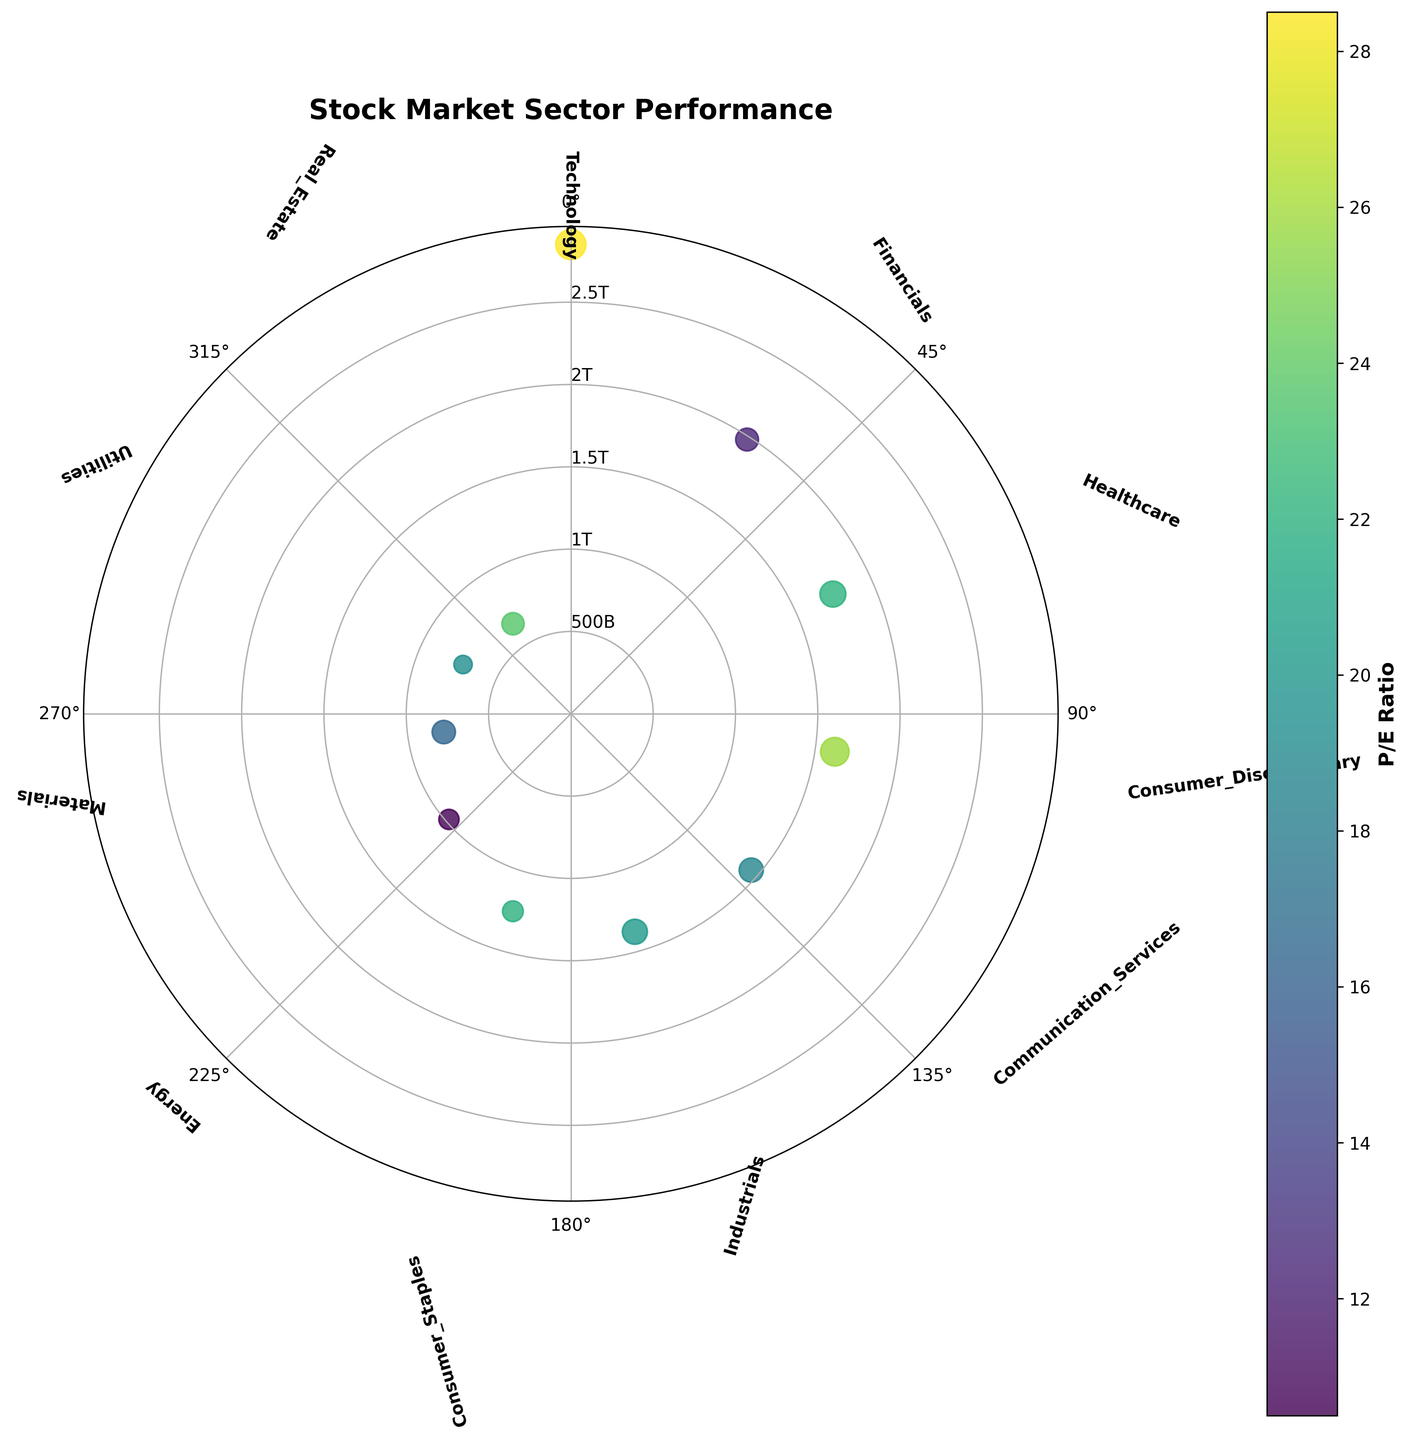What is the title of the plot? The title is found at the top of the plot. It provides a summary of what the figure represents. The title is "Stock Market Sector Performance".
Answer: Stock Market Sector Performance What does the color of the points represent? The color of the points on the plot indicates the P/E Ratio of each sector, which is shown by the colorbar on the right side of the plot.
Answer: P/E Ratio How many sectors are represented in the plot? By counting the number of unique points with sector labels around the plot, we can determine the total. There are 11 sectors labeled around the figure.
Answer: 11 Which sector has the highest market cap? The sector with the point farthest from the center represents the highest market cap. The furthest point is labeled "Technology" at approximately 2850 billion.
Answer: Technology Which sector has the smallest size of the scatter point? The size of the scatter points represents sector performance. By visual inspection, the smallest scatter point corresponds to the Utilities sector.
Answer: Utilities What is the relationship between the distance from the center of the plot and the scatter plot data? The distance from the center (r) represents the Market Cap in billions. Sectors farther from the center have higher market cap values.
Answer: Market Cap in billions Which sector has the highest P/E ratio and what is its value? The darkest colored point on the plot corresponds to the highest P/E Ratio. Checking the color-to-value correspondence, Real_Estate has the highest P/E ratio of approximately 23.7.
Answer: Real_Estate, 23.7 Which two sectors have P/E ratios greater than 25? By inspecting the darkest colored points, Technology and Consumer_Discretionary are the sectors with P/E ratios above 25.
Answer: Technology, Consumer_Discretionary How does Consumer_Staples compare in market cap and sector performance to Energy? Consumer_Staples has a market cap of 1250 billion and sector performance of 7.2, while Energy has a market cap of 980 billion and sector performance of 6.8. Comparing these values, Consumer_Staples has a larger market cap and slightly higher performance.
Answer: Larger market cap, slightly higher performance What is the average sector performance of Technology and Healthcare? Sector performance values are 15.2 for Technology and 11.3 for Healthcare. Adding them (15.2 + 11.3) results in 26.5. The average is 26.5 / 2 = 13.25.
Answer: 13.25 